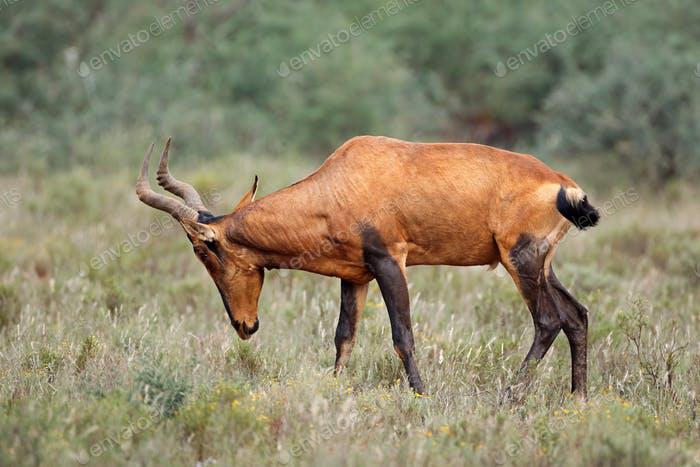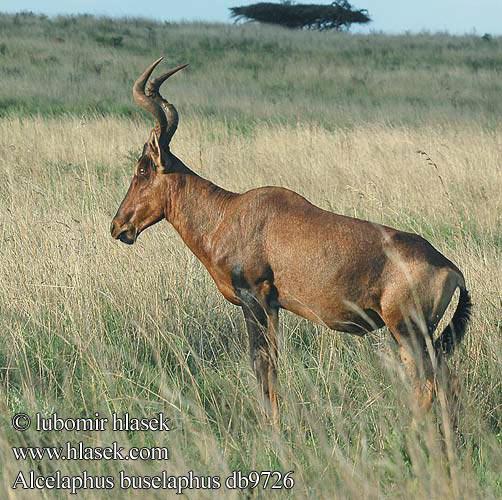The first image is the image on the left, the second image is the image on the right. Considering the images on both sides, is "The left and right image contains the same number of standing elk." valid? Answer yes or no. Yes. The first image is the image on the left, the second image is the image on the right. Assess this claim about the two images: "Each image contains one horned animal, and the animals on the left and right have their heads turned in the same direction.". Correct or not? Answer yes or no. Yes. 